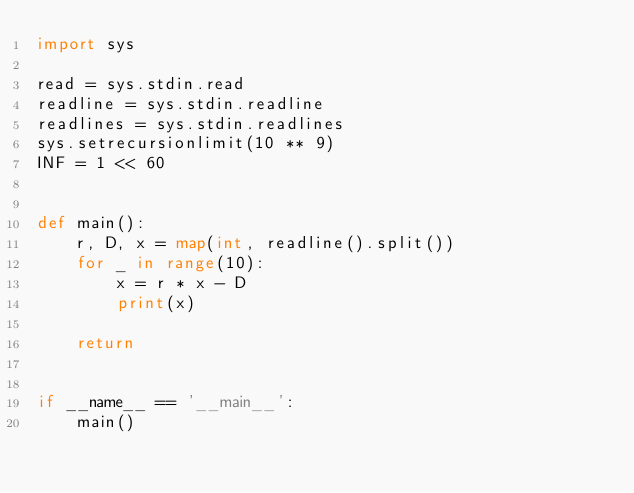<code> <loc_0><loc_0><loc_500><loc_500><_Python_>import sys

read = sys.stdin.read
readline = sys.stdin.readline
readlines = sys.stdin.readlines
sys.setrecursionlimit(10 ** 9)
INF = 1 << 60


def main():
    r, D, x = map(int, readline().split())
    for _ in range(10):
        x = r * x - D
        print(x)
    
    return


if __name__ == '__main__':
    main()
</code> 